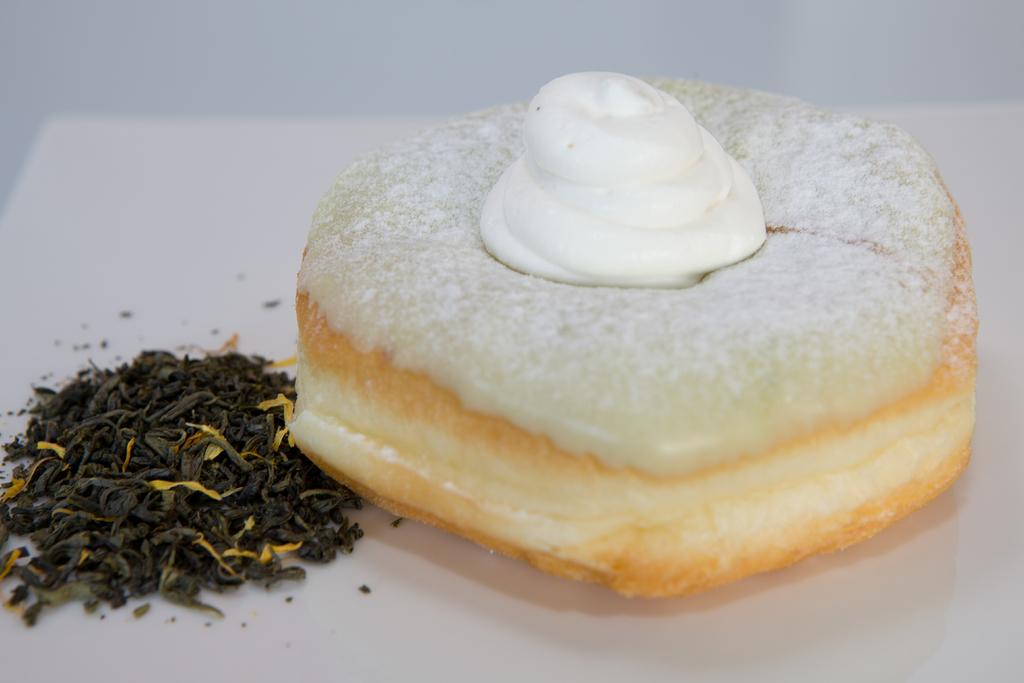What type of objects can be seen in the image? There are food items in the image. On what surface are the food items placed? The food items are placed on a white surface. How many rabbits can be seen in the image? There are no rabbits present in the image. What type of hen is visible in the image? There is no hen present in the image. 